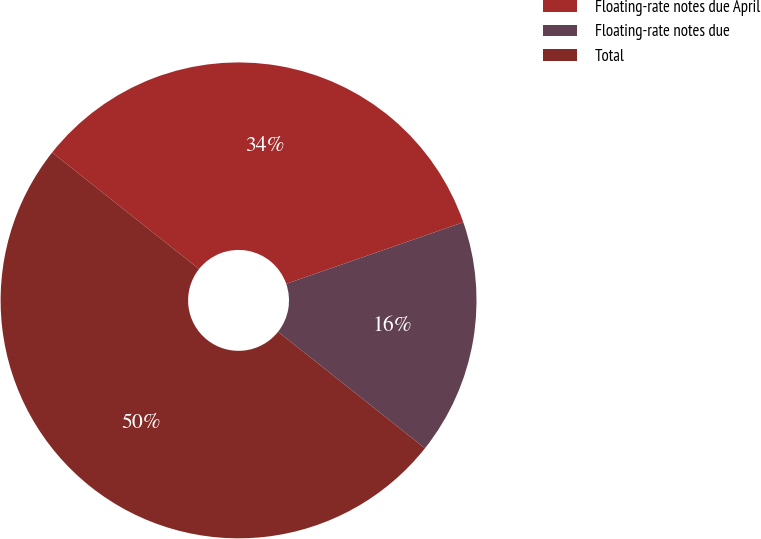Convert chart to OTSL. <chart><loc_0><loc_0><loc_500><loc_500><pie_chart><fcel>Floating-rate notes due April<fcel>Floating-rate notes due<fcel>Total<nl><fcel>34.0%<fcel>16.0%<fcel>50.0%<nl></chart> 